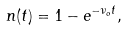Convert formula to latex. <formula><loc_0><loc_0><loc_500><loc_500>n ( t ) = 1 - e ^ { - \nu _ { o } t } ,</formula> 